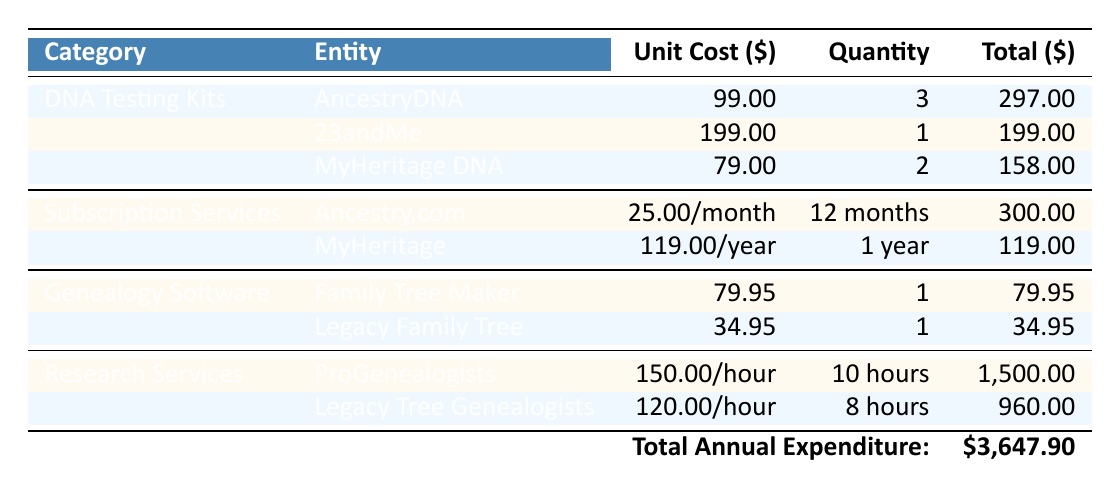What is the total expenditure on DNA Testing Kits? To find the total expenditure on DNA Testing Kits, we sum the Total Cost of all entries under that category: 297 (AncestryDNA) + 199 (23andMe) + 158 (MyHeritage DNA) = 654.
Answer: 654 Which subscription service has the highest total cost? Comparing the Total Cost of the subscription services: Ancestry.com has 300 and MyHeritage has 119. Since 300 is greater than 119, Ancestry.com is the service with the highest total cost.
Answer: Ancestry.com What is the cost of one unit of Legacy Family Tree software? The table displays the CostPerUnit for Legacy Family Tree as 34.95, so the cost of one unit is simply that value.
Answer: 34.95 Is the total expenditure on Research Services greater than 2,000? We can add the Total Costs for the Research Services: 1500 (ProGenealogists) + 960 (Legacy Tree Genealogists) = 2460. Since 2460 is greater than 2000, the statement is true.
Answer: Yes What is the average cost of the DNA testing kits purchased? For averaging, we consider the total cost of DNA testing kits (654 from the first question) divided by the quantity purchased (3 + 1 + 2 = 6). Thus, 654/6 = 109. The average cost of DNA testing kits is therefore 109.
Answer: 109 Which genealogy software has the lowest total cost? Checking the Total Cost for both genealogy software entries, Family Tree Maker has 79.95 and Legacy Family Tree has 34.95. Since 34.95 is lower, Legacy Family Tree has the lowest total cost.
Answer: Legacy Family Tree What is the total annual expenditure on all categories? To calculate the total annual expenditure, we add all Total Costs from each category: 297 (AncestryDNA) + 199 (23andMe) + 158 (MyHeritage DNA) + 300 (Ancestry.com) + 119 (MyHeritage) + 79.95 (Family Tree Maker) + 34.95 (Legacy Family Tree) + 1500 (ProGenealogists) + 960 (Legacy Tree Genealogists) = 3647.90.
Answer: 3647.90 Is the combined expenditure on Subscriptions lower than 400? We add the Total Costs of Subscription Services: 300 (Ancestry.com) + 119 (MyHeritage) = 419. Since 419 is greater than 400, the statement is false.
Answer: No How much more was spent on Research Services compared to DNA Testing Kits? First, we find the total spent on Research Services (2460) and the total on DNA Testing Kits (654). The difference is 2460 - 654 = 1806, indicating that 1806 more was spent on Research Services than on DNA Testing Kits.
Answer: 1806 